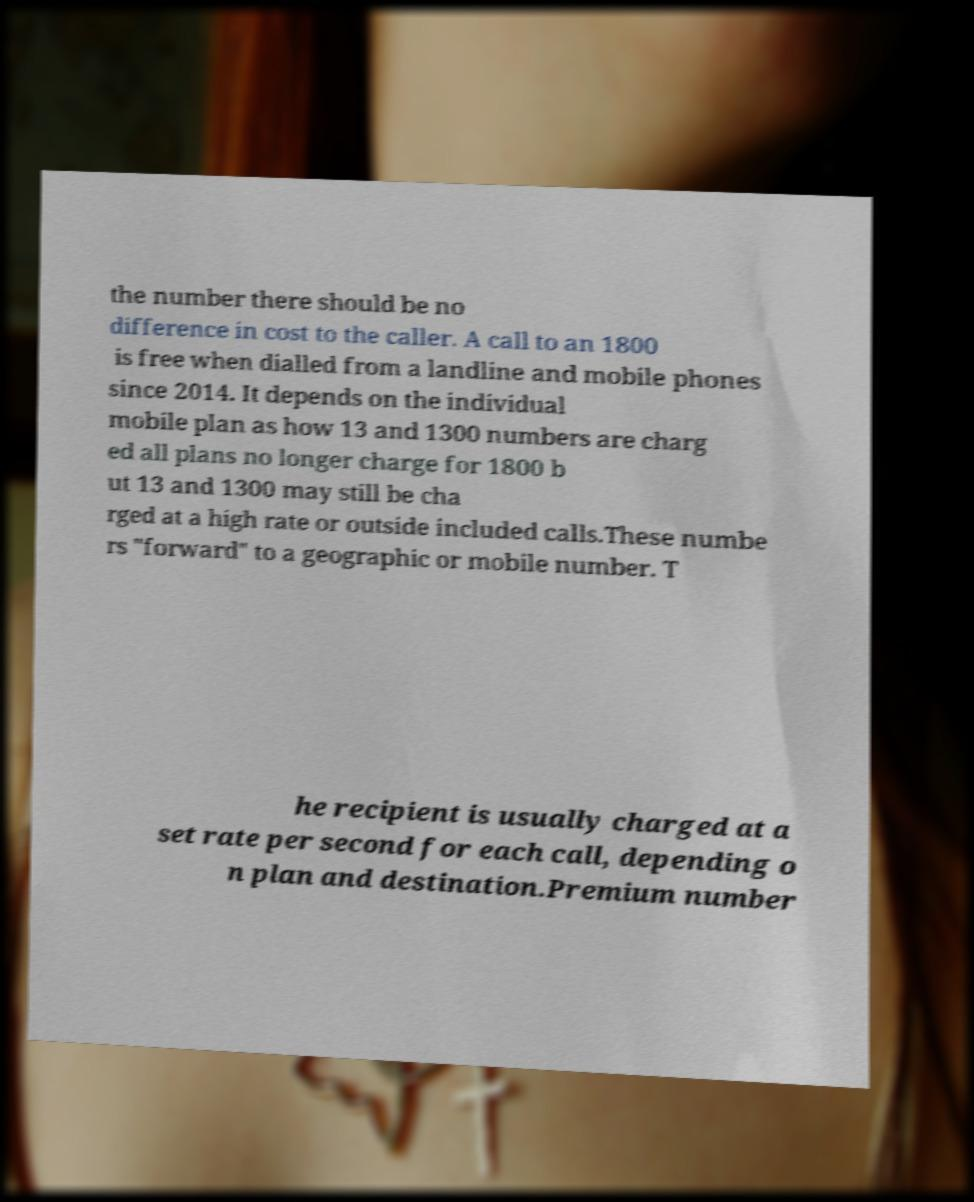Please read and relay the text visible in this image. What does it say? the number there should be no difference in cost to the caller. A call to an 1800 is free when dialled from a landline and mobile phones since 2014. It depends on the individual mobile plan as how 13 and 1300 numbers are charg ed all plans no longer charge for 1800 b ut 13 and 1300 may still be cha rged at a high rate or outside included calls.These numbe rs "forward" to a geographic or mobile number. T he recipient is usually charged at a set rate per second for each call, depending o n plan and destination.Premium number 